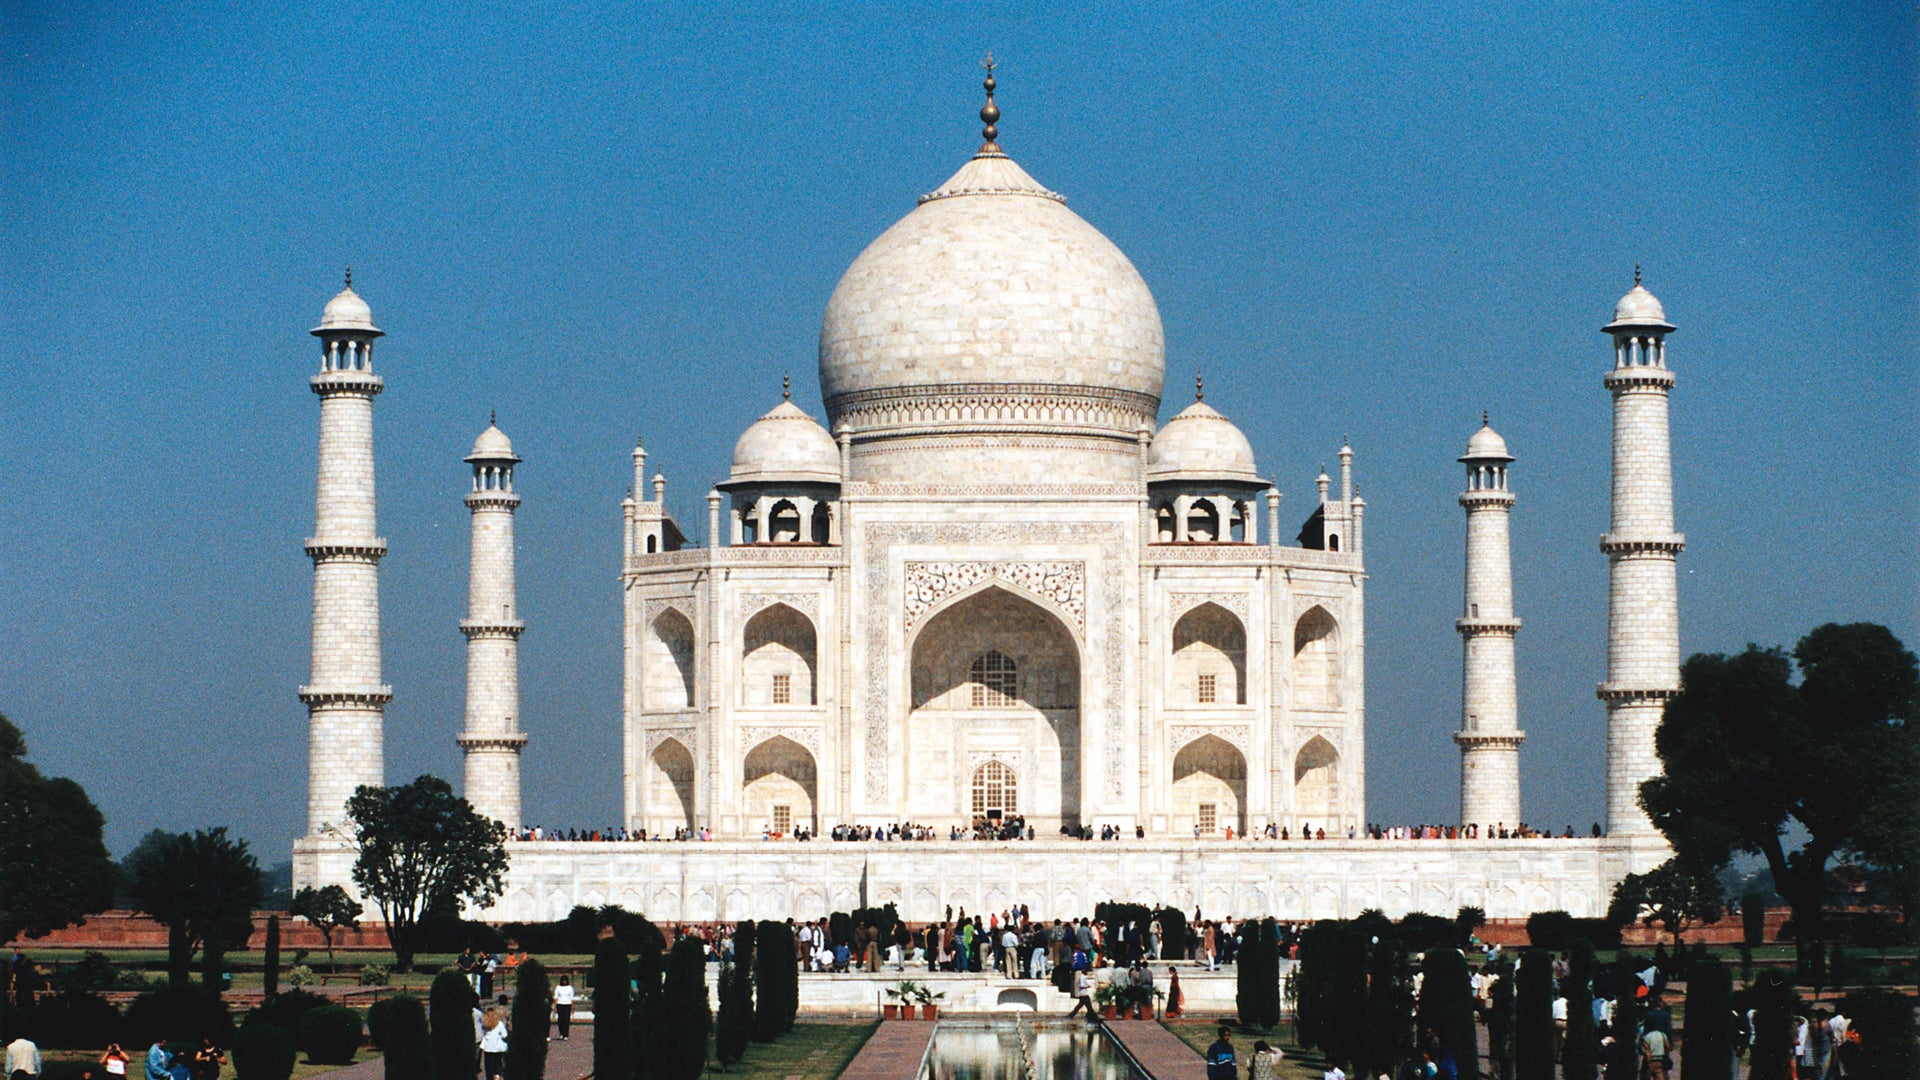Are there any notable design elements specific to the Taj Mahal? Yes, the Taj Mahal is renowned for several unique design elements. One of the most striking is the extensive use of white marble which appears to change color with the changing light of the day, glowing pink at dawn, milky white in the evening, and golden under the moonlight. The central dome is framed by four smaller domed pavilions, and the main dome is topped with a lotus design which contributes to its astonishing height which is often seen as a symbol reaching towards the heavens. Additionally, the complex is adorned with calligraphy of Quranic verses and the interior chambers are sanctified with intricate lapidary of floral motifs and gemstones. 